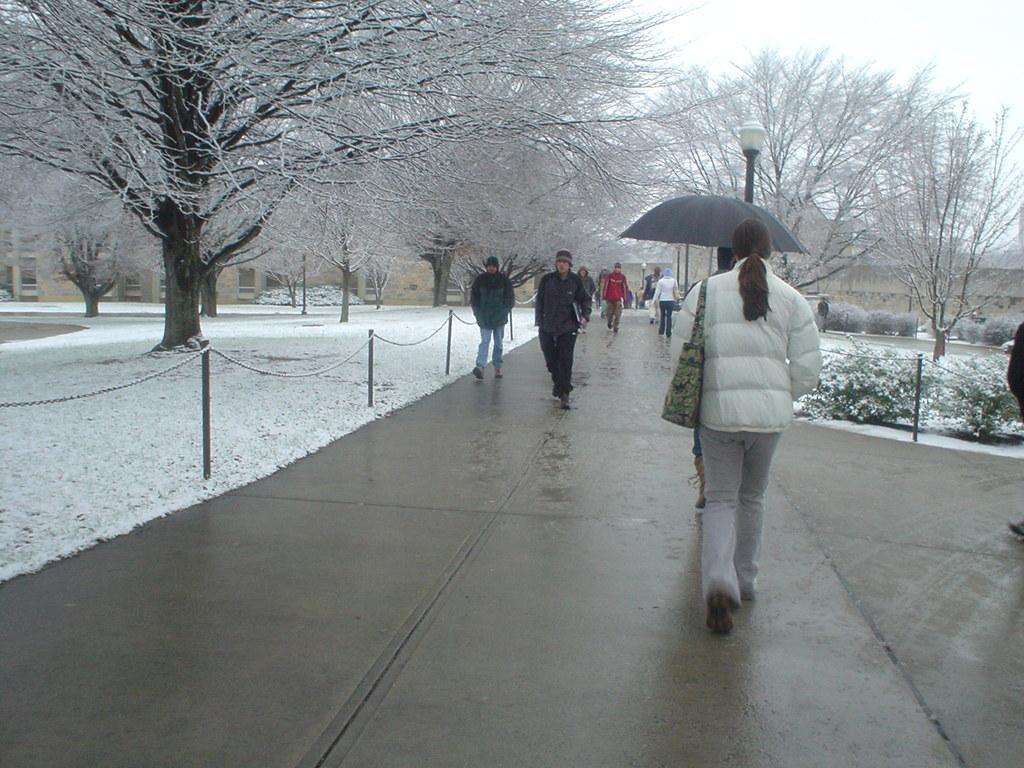Please provide a concise description of this image. In the image we can see there are people walking, they are wearing clothes, shoes and some of them are wearing shoes and carrying bags. Here we can see an umbrella, footpath, chain and the poles. Here we can see plants, snow, trees, the light pole and the sky. 